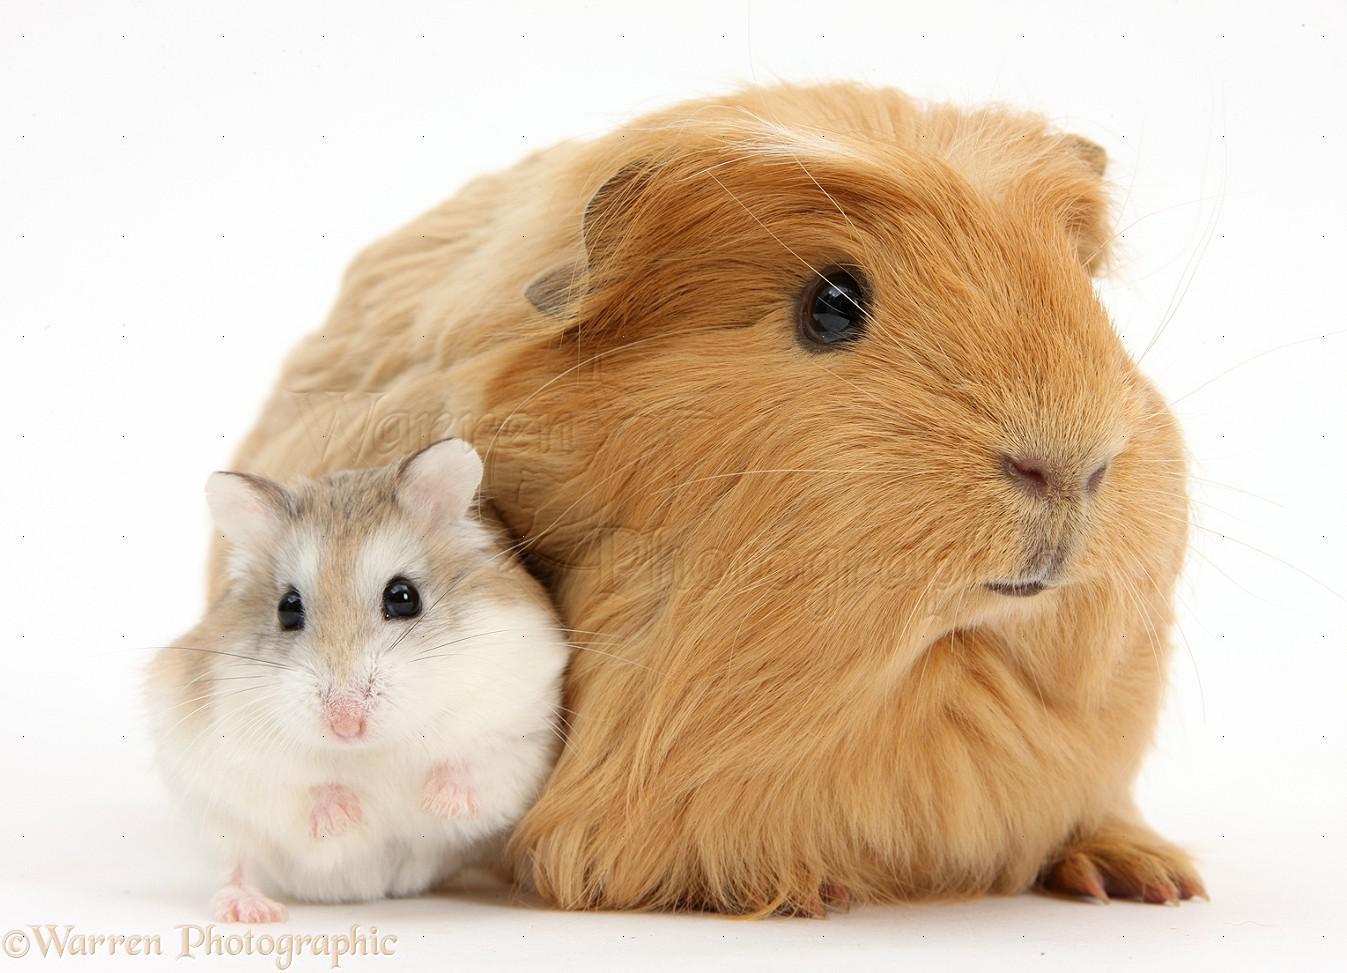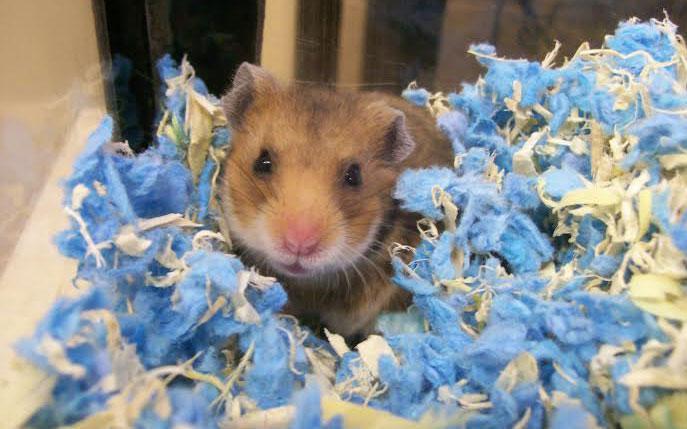The first image is the image on the left, the second image is the image on the right. For the images displayed, is the sentence "An image includes a furry orange-and-white guinea pig near a smaller, shorter-haired rodent." factually correct? Answer yes or no. No. The first image is the image on the left, the second image is the image on the right. Assess this claim about the two images: "The hamster in one of the images is in a wire cage.". Correct or not? Answer yes or no. No. 